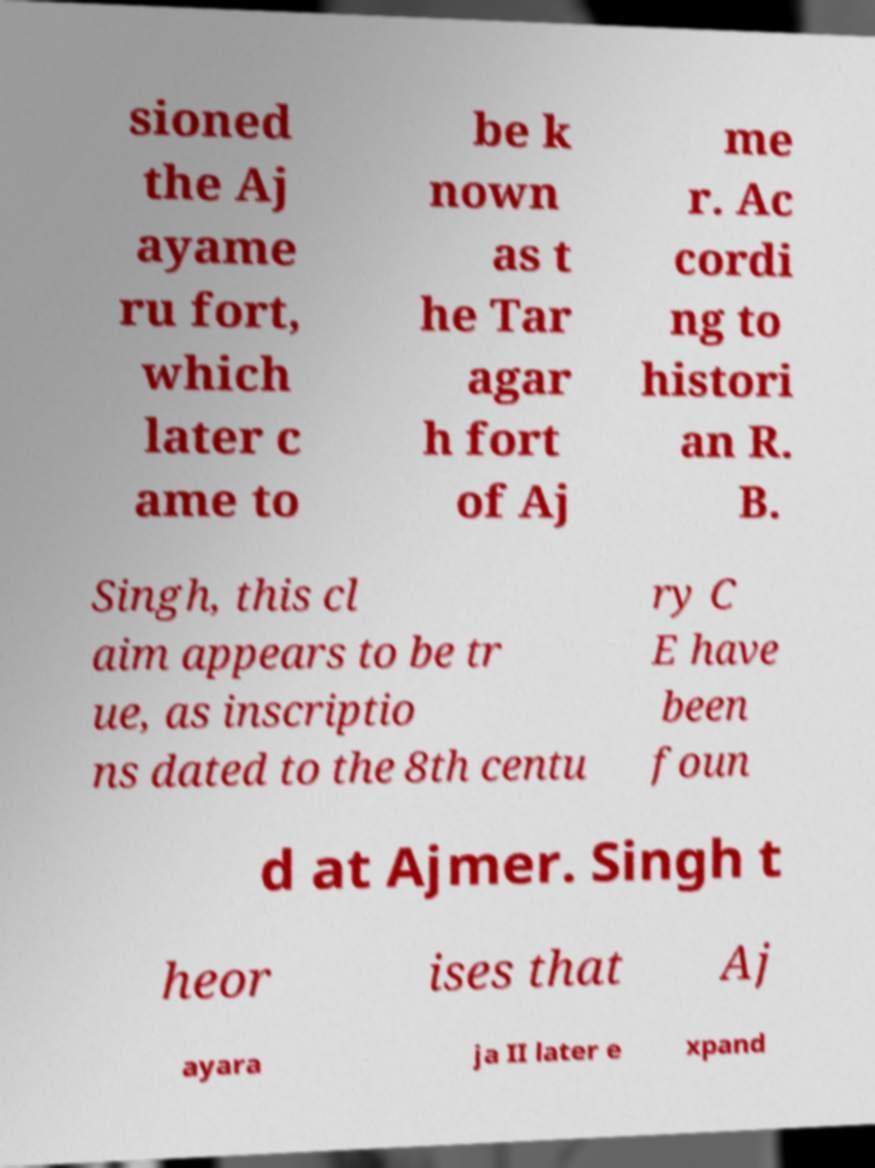Could you assist in decoding the text presented in this image and type it out clearly? sioned the Aj ayame ru fort, which later c ame to be k nown as t he Tar agar h fort of Aj me r. Ac cordi ng to histori an R. B. Singh, this cl aim appears to be tr ue, as inscriptio ns dated to the 8th centu ry C E have been foun d at Ajmer. Singh t heor ises that Aj ayara ja II later e xpand 